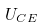Convert formula to latex. <formula><loc_0><loc_0><loc_500><loc_500>U _ { C E }</formula> 